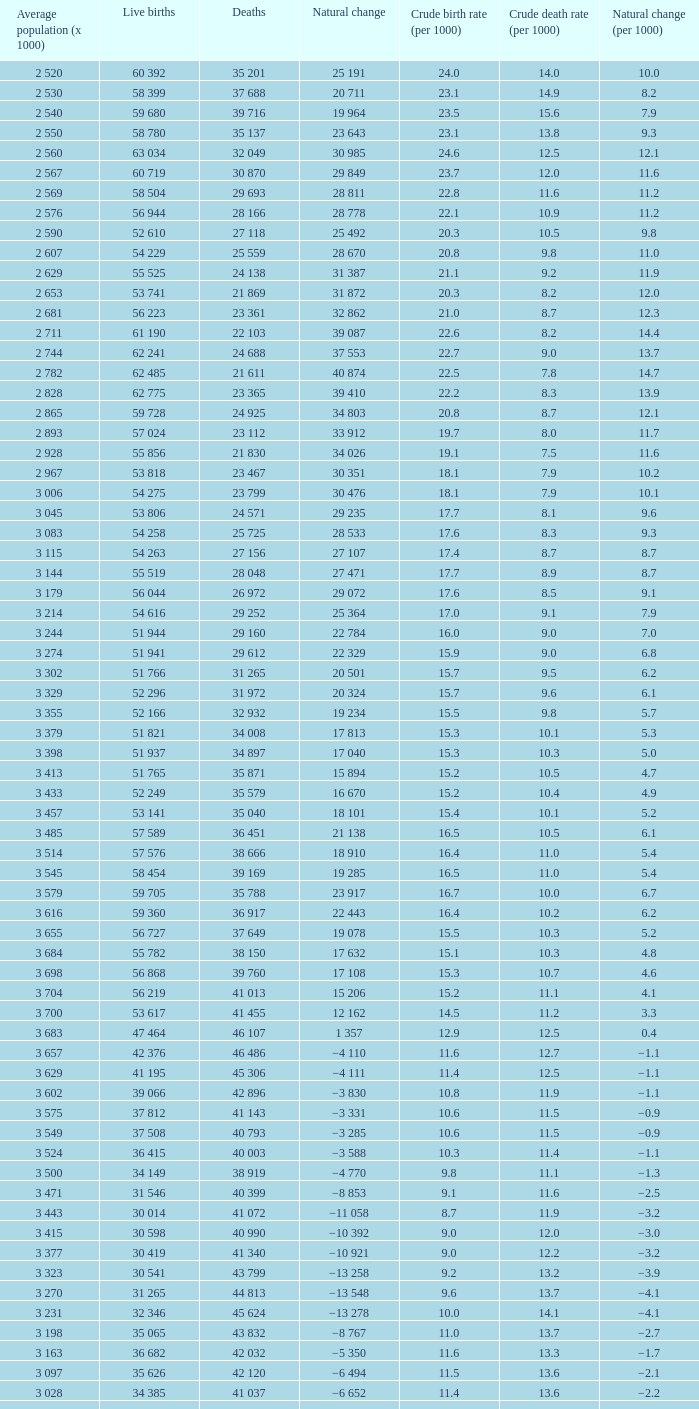Which Natural change has a Crude death rate (per 1000) larger than 9, and Deaths of 40 399? −8 853. I'm looking to parse the entire table for insights. Could you assist me with that? {'header': ['Average population (x 1000)', 'Live births', 'Deaths', 'Natural change', 'Crude birth rate (per 1000)', 'Crude death rate (per 1000)', 'Natural change (per 1000)'], 'rows': [['2 520', '60 392', '35 201', '25 191', '24.0', '14.0', '10.0'], ['2 530', '58 399', '37 688', '20 711', '23.1', '14.9', '8.2'], ['2 540', '59 680', '39 716', '19 964', '23.5', '15.6', '7.9'], ['2 550', '58 780', '35 137', '23 643', '23.1', '13.8', '9.3'], ['2 560', '63 034', '32 049', '30 985', '24.6', '12.5', '12.1'], ['2 567', '60 719', '30 870', '29 849', '23.7', '12.0', '11.6'], ['2 569', '58 504', '29 693', '28 811', '22.8', '11.6', '11.2'], ['2 576', '56 944', '28 166', '28 778', '22.1', '10.9', '11.2'], ['2 590', '52 610', '27 118', '25 492', '20.3', '10.5', '9.8'], ['2 607', '54 229', '25 559', '28 670', '20.8', '9.8', '11.0'], ['2 629', '55 525', '24 138', '31 387', '21.1', '9.2', '11.9'], ['2 653', '53 741', '21 869', '31 872', '20.3', '8.2', '12.0'], ['2 681', '56 223', '23 361', '32 862', '21.0', '8.7', '12.3'], ['2 711', '61 190', '22 103', '39 087', '22.6', '8.2', '14.4'], ['2 744', '62 241', '24 688', '37 553', '22.7', '9.0', '13.7'], ['2 782', '62 485', '21 611', '40 874', '22.5', '7.8', '14.7'], ['2 828', '62 775', '23 365', '39 410', '22.2', '8.3', '13.9'], ['2 865', '59 728', '24 925', '34 803', '20.8', '8.7', '12.1'], ['2 893', '57 024', '23 112', '33 912', '19.7', '8.0', '11.7'], ['2 928', '55 856', '21 830', '34 026', '19.1', '7.5', '11.6'], ['2 967', '53 818', '23 467', '30 351', '18.1', '7.9', '10.2'], ['3 006', '54 275', '23 799', '30 476', '18.1', '7.9', '10.1'], ['3 045', '53 806', '24 571', '29 235', '17.7', '8.1', '9.6'], ['3 083', '54 258', '25 725', '28 533', '17.6', '8.3', '9.3'], ['3 115', '54 263', '27 156', '27 107', '17.4', '8.7', '8.7'], ['3 144', '55 519', '28 048', '27 471', '17.7', '8.9', '8.7'], ['3 179', '56 044', '26 972', '29 072', '17.6', '8.5', '9.1'], ['3 214', '54 616', '29 252', '25 364', '17.0', '9.1', '7.9'], ['3 244', '51 944', '29 160', '22 784', '16.0', '9.0', '7.0'], ['3 274', '51 941', '29 612', '22 329', '15.9', '9.0', '6.8'], ['3 302', '51 766', '31 265', '20 501', '15.7', '9.5', '6.2'], ['3 329', '52 296', '31 972', '20 324', '15.7', '9.6', '6.1'], ['3 355', '52 166', '32 932', '19 234', '15.5', '9.8', '5.7'], ['3 379', '51 821', '34 008', '17 813', '15.3', '10.1', '5.3'], ['3 398', '51 937', '34 897', '17 040', '15.3', '10.3', '5.0'], ['3 413', '51 765', '35 871', '15 894', '15.2', '10.5', '4.7'], ['3 433', '52 249', '35 579', '16 670', '15.2', '10.4', '4.9'], ['3 457', '53 141', '35 040', '18 101', '15.4', '10.1', '5.2'], ['3 485', '57 589', '36 451', '21 138', '16.5', '10.5', '6.1'], ['3 514', '57 576', '38 666', '18 910', '16.4', '11.0', '5.4'], ['3 545', '58 454', '39 169', '19 285', '16.5', '11.0', '5.4'], ['3 579', '59 705', '35 788', '23 917', '16.7', '10.0', '6.7'], ['3 616', '59 360', '36 917', '22 443', '16.4', '10.2', '6.2'], ['3 655', '56 727', '37 649', '19 078', '15.5', '10.3', '5.2'], ['3 684', '55 782', '38 150', '17 632', '15.1', '10.3', '4.8'], ['3 698', '56 868', '39 760', '17 108', '15.3', '10.7', '4.6'], ['3 704', '56 219', '41 013', '15 206', '15.2', '11.1', '4.1'], ['3 700', '53 617', '41 455', '12 162', '14.5', '11.2', '3.3'], ['3 683', '47 464', '46 107', '1 357', '12.9', '12.5', '0.4'], ['3 657', '42 376', '46 486', '−4 110', '11.6', '12.7', '−1.1'], ['3 629', '41 195', '45 306', '−4 111', '11.4', '12.5', '−1.1'], ['3 602', '39 066', '42 896', '−3 830', '10.8', '11.9', '−1.1'], ['3 575', '37 812', '41 143', '−3 331', '10.6', '11.5', '−0.9'], ['3 549', '37 508', '40 793', '−3 285', '10.6', '11.5', '−0.9'], ['3 524', '36 415', '40 003', '−3 588', '10.3', '11.4', '−1.1'], ['3 500', '34 149', '38 919', '−4 770', '9.8', '11.1', '−1.3'], ['3 471', '31 546', '40 399', '−8 853', '9.1', '11.6', '−2.5'], ['3 443', '30 014', '41 072', '−11 058', '8.7', '11.9', '−3.2'], ['3 415', '30 598', '40 990', '−10 392', '9.0', '12.0', '−3.0'], ['3 377', '30 419', '41 340', '−10 921', '9.0', '12.2', '−3.2'], ['3 323', '30 541', '43 799', '−13 258', '9.2', '13.2', '−3.9'], ['3 270', '31 265', '44 813', '−13 548', '9.6', '13.7', '−4.1'], ['3 231', '32 346', '45 624', '−13 278', '10.0', '14.1', '−4.1'], ['3 198', '35 065', '43 832', '−8 767', '11.0', '13.7', '−2.7'], ['3 163', '36 682', '42 032', '−5 350', '11.6', '13.3', '−1.7'], ['3 097', '35 626', '42 120', '−6 494', '11.5', '13.6', '−2.1'], ['3 028', '34 385', '41 037', '−6 652', '11.4', '13.6', '−2.2'], ['2 988', '30 459', '40 938', '−10 479', '10.2', '13.7', '−3.5']]} 